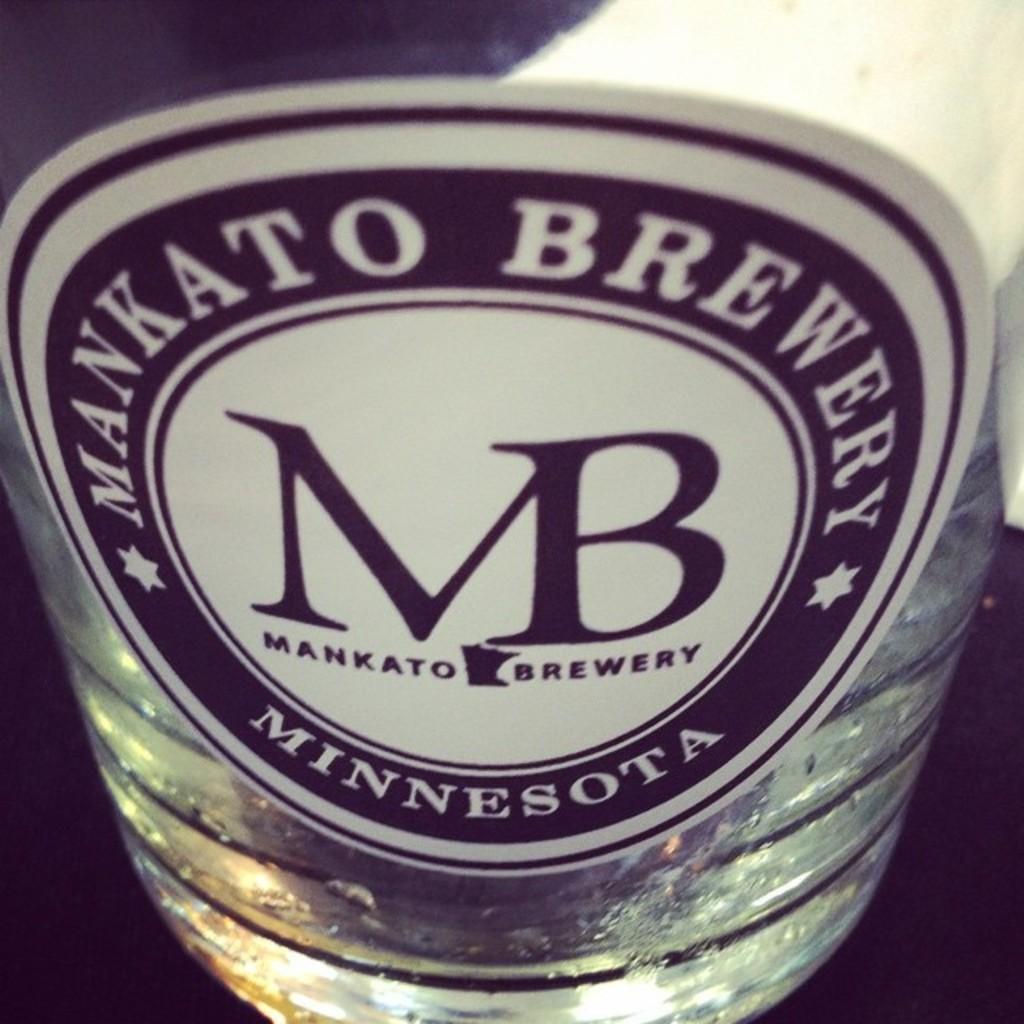Describe this image in one or two sentences. In this image I can see a bottle and one sticker is attached to it. 